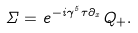Convert formula to latex. <formula><loc_0><loc_0><loc_500><loc_500>\Sigma = e ^ { - i \gamma ^ { 5 } \tau \partial _ { x } } Q _ { + } .</formula> 